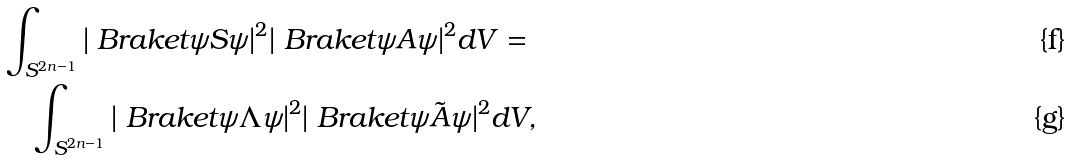<formula> <loc_0><loc_0><loc_500><loc_500>& \int _ { S ^ { 2 n - 1 } } | \ B r a k e t { \psi } { S } { \psi } | ^ { 2 } | \ B r a k e t { \psi } { A } { \psi } | ^ { 2 } d V = \\ & \quad \int _ { S ^ { 2 n - 1 } } | \ B r a k e t { \psi } { \Lambda } { \psi } | ^ { 2 } | \ B r a k e t { \psi } { \tilde { A } } { \psi } | ^ { 2 } d V ,</formula> 